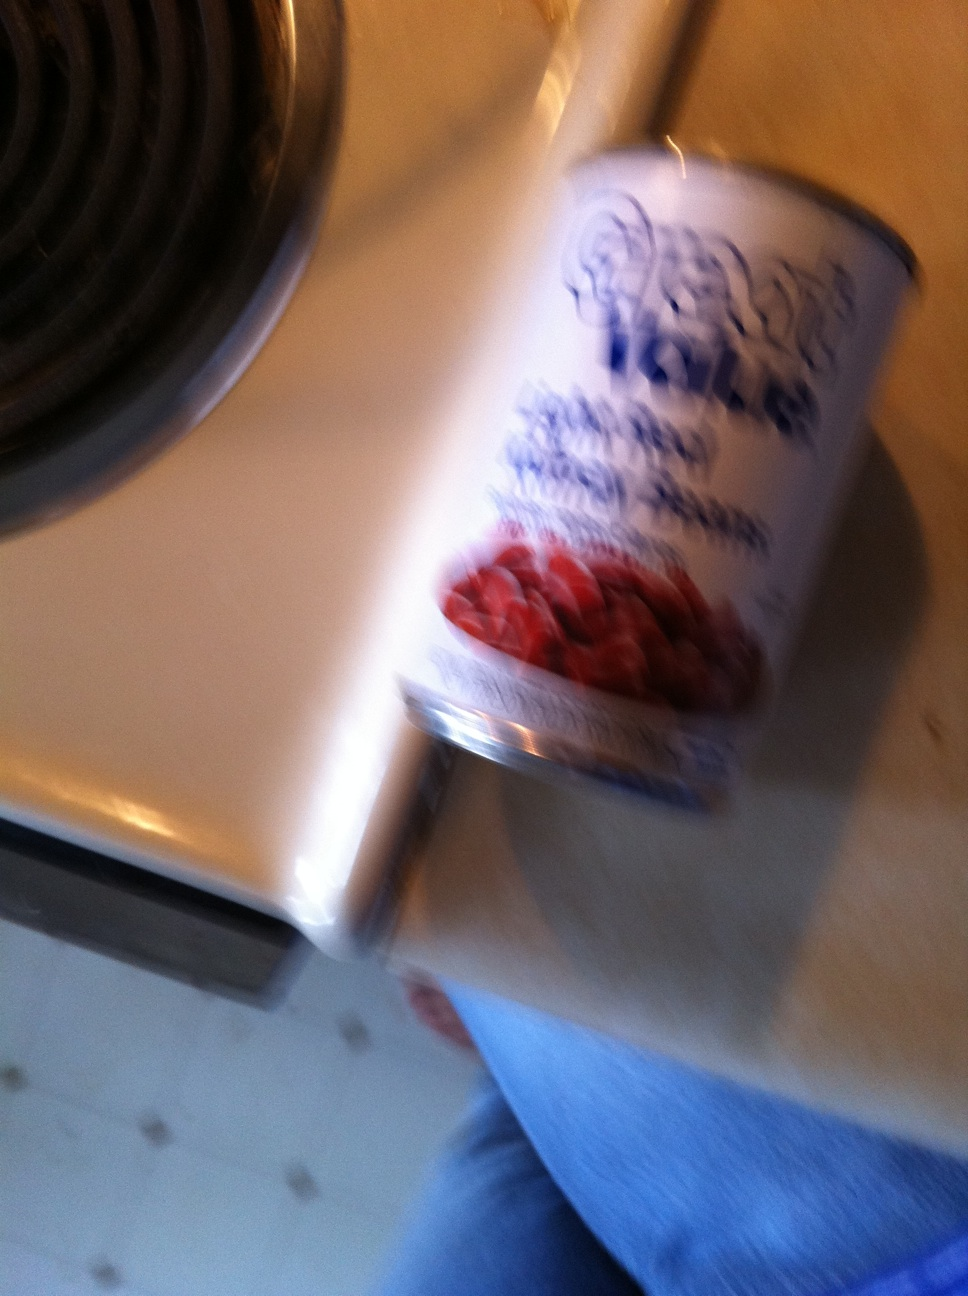What recipes could these beans be used for? Beans are incredibly versatile and can be used in a range of recipes such as chili, salads, soups, stews, or as a protein-rich addition to vegetarian and vegan dishes. 